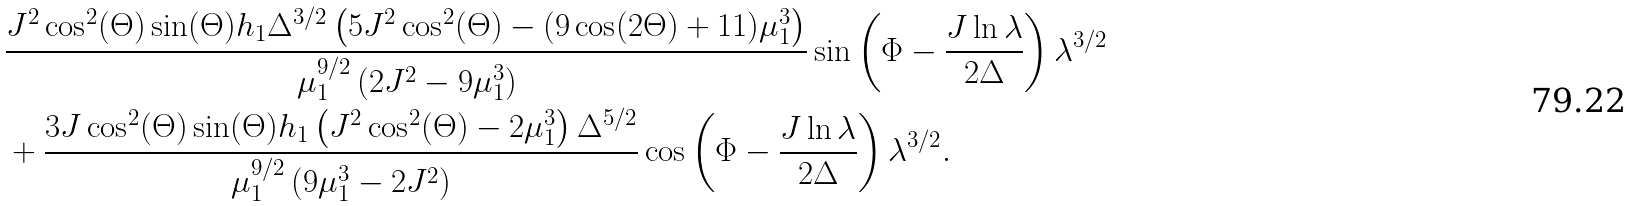Convert formula to latex. <formula><loc_0><loc_0><loc_500><loc_500>& \frac { J ^ { 2 } \cos ^ { 2 } ( \Theta ) \sin ( \Theta ) h _ { 1 } \Delta ^ { 3 / 2 } \left ( 5 J ^ { 2 } \cos ^ { 2 } ( \Theta ) - ( 9 \cos ( 2 \Theta ) + 1 1 ) \mu _ { 1 } ^ { 3 } \right ) } { \mu _ { 1 } ^ { 9 / 2 } \left ( 2 J ^ { 2 } - 9 \mu _ { 1 } ^ { 3 } \right ) } \sin \left ( \Phi - \frac { J \ln \lambda } { 2 \Delta } \right ) \lambda ^ { 3 / 2 } \\ & + \frac { 3 J \cos ^ { 2 } ( \Theta ) \sin ( \Theta ) h _ { 1 } \left ( J ^ { 2 } \cos ^ { 2 } ( \Theta ) - 2 \mu _ { 1 } ^ { 3 } \right ) \Delta ^ { 5 / 2 } } { \mu _ { 1 } ^ { 9 / 2 } \left ( 9 \mu _ { 1 } ^ { 3 } - 2 J ^ { 2 } \right ) } \cos \left ( \Phi - \frac { J \ln \lambda } { 2 \Delta } \right ) \lambda ^ { 3 / 2 } .</formula> 